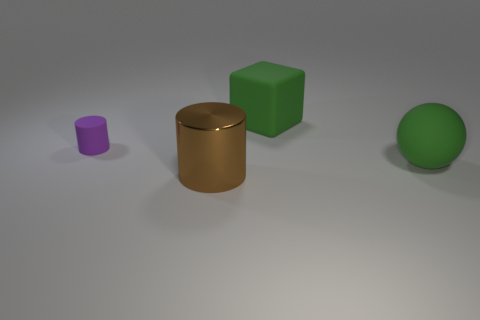How many things are either green rubber balls or big brown metal objects?
Keep it short and to the point. 2. Is there anything else that has the same material as the brown cylinder?
Provide a short and direct response. No. There is a small purple thing; what shape is it?
Make the answer very short. Cylinder. There is a big matte thing that is behind the cylinder that is to the left of the big cylinder; what shape is it?
Give a very brief answer. Cube. Is the material of the cube that is behind the big ball the same as the large green ball?
Your answer should be very brief. Yes. What number of green things are either rubber blocks or tiny things?
Make the answer very short. 1. Are there any large objects that have the same color as the block?
Keep it short and to the point. Yes. Is there a green ball that has the same material as the small purple object?
Offer a terse response. Yes. What shape is the matte thing that is both to the left of the ball and on the right side of the tiny matte object?
Make the answer very short. Cube. How many large objects are brown metallic things or red cylinders?
Make the answer very short. 1. 